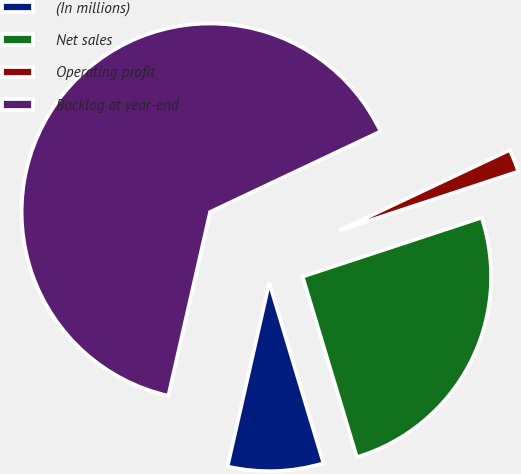Convert chart to OTSL. <chart><loc_0><loc_0><loc_500><loc_500><pie_chart><fcel>(In millions)<fcel>Net sales<fcel>Operating profit<fcel>Backlog at year-end<nl><fcel>8.2%<fcel>25.42%<fcel>1.96%<fcel>64.42%<nl></chart> 